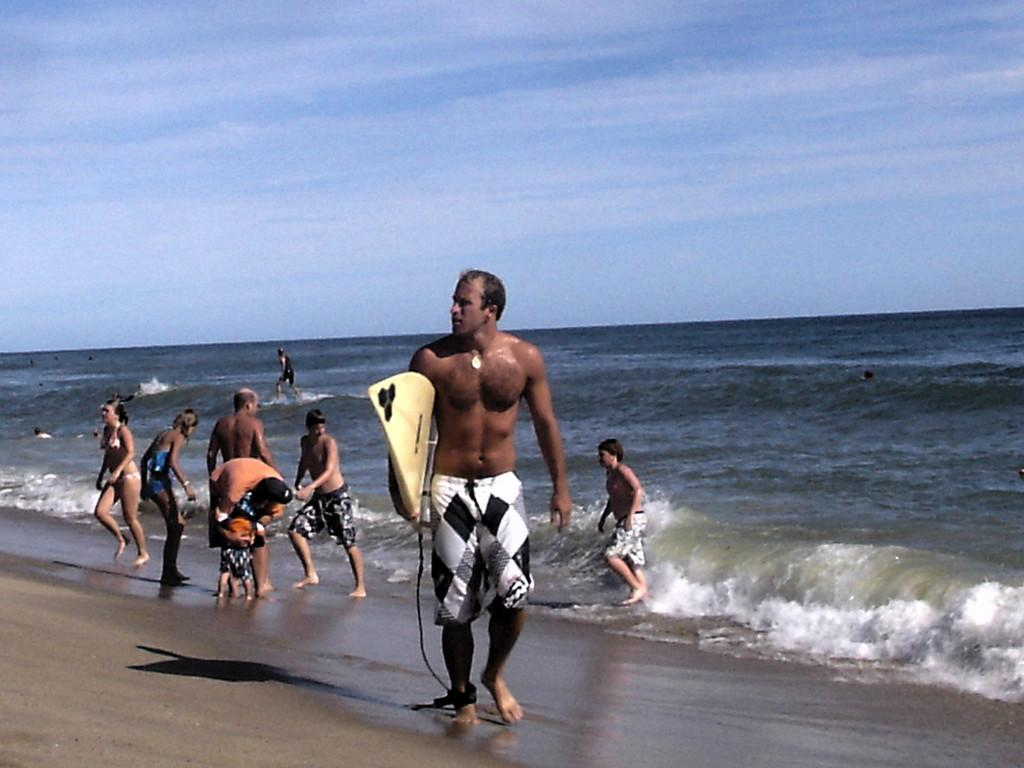How many people are in the image? There are people in the image, but the exact number is not specified. What is one person holding in the image? One person is holding a board in the image. What type of terrain is at the bottom of the image? There is sand and water at the bottom of the image. What is visible at the top of the image? The sky is visible at the top of the image. Where is the hose located in the image? There is no hose present in the image. What type of chain can be seen connecting the people in the image? There is no chain connecting the people in the image. 